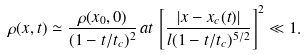<formula> <loc_0><loc_0><loc_500><loc_500>\rho ( x , t ) \simeq \frac { \rho ( x _ { 0 } , 0 ) } { ( 1 - t / t _ { c } ) ^ { 2 } } \, a t \, \left [ \frac { \left | x - x _ { c } ( t ) \right | } { l ( 1 - t / t _ { c } ) ^ { 5 / 2 } } \right ] ^ { 2 } \ll 1 .</formula> 